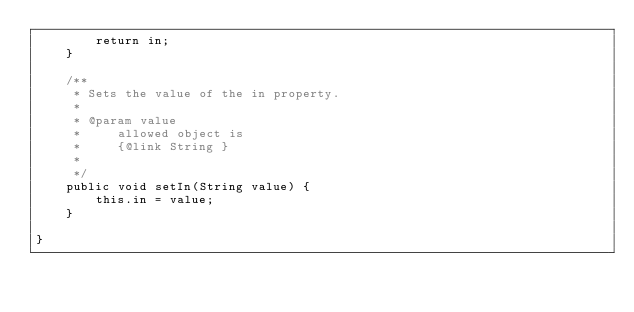Convert code to text. <code><loc_0><loc_0><loc_500><loc_500><_Java_>        return in;
    }

    /**
     * Sets the value of the in property.
     * 
     * @param value
     *     allowed object is
     *     {@link String }
     *     
     */
    public void setIn(String value) {
        this.in = value;
    }

}
</code> 